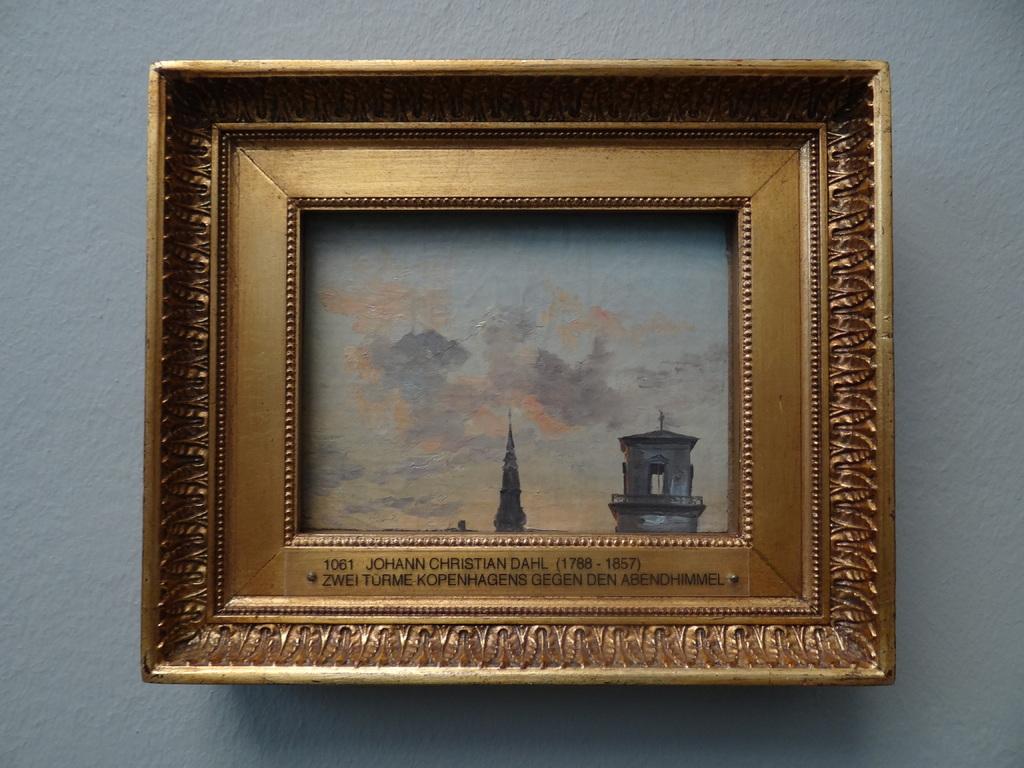What is johann's full name?
Make the answer very short. Johann christian dahl. What year was the artist born?
Your answer should be compact. 1788. 